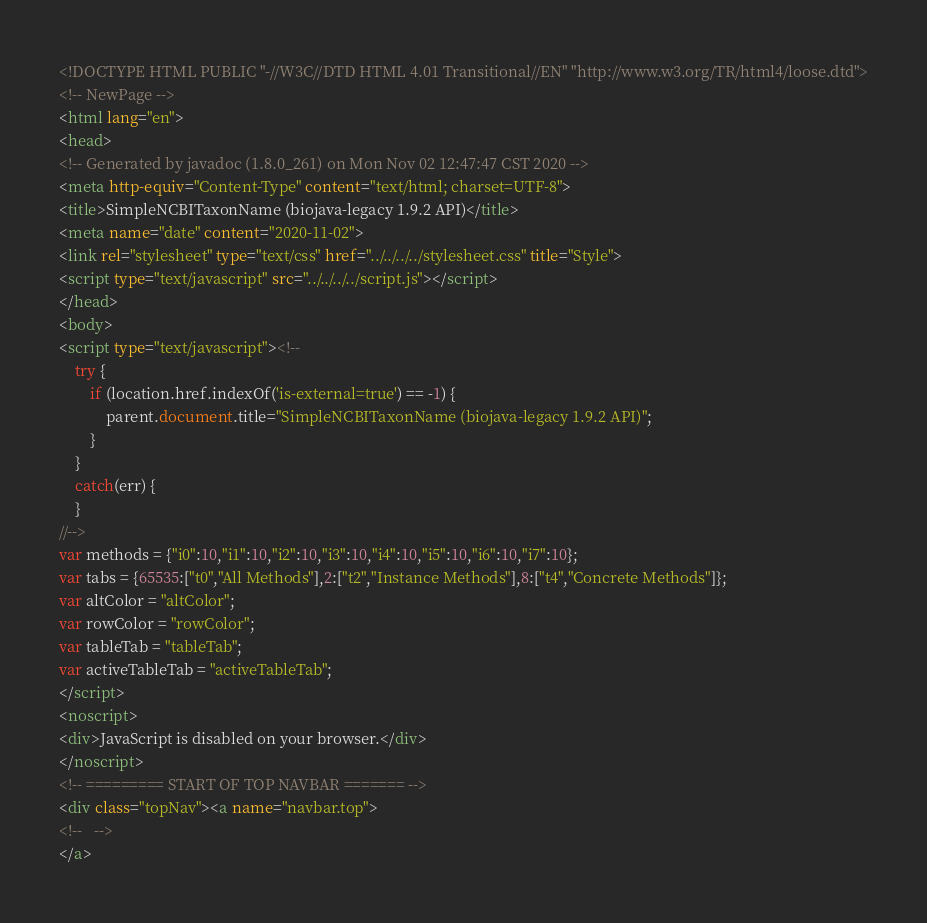<code> <loc_0><loc_0><loc_500><loc_500><_HTML_><!DOCTYPE HTML PUBLIC "-//W3C//DTD HTML 4.01 Transitional//EN" "http://www.w3.org/TR/html4/loose.dtd">
<!-- NewPage -->
<html lang="en">
<head>
<!-- Generated by javadoc (1.8.0_261) on Mon Nov 02 12:47:47 CST 2020 -->
<meta http-equiv="Content-Type" content="text/html; charset=UTF-8">
<title>SimpleNCBITaxonName (biojava-legacy 1.9.2 API)</title>
<meta name="date" content="2020-11-02">
<link rel="stylesheet" type="text/css" href="../../../../stylesheet.css" title="Style">
<script type="text/javascript" src="../../../../script.js"></script>
</head>
<body>
<script type="text/javascript"><!--
    try {
        if (location.href.indexOf('is-external=true') == -1) {
            parent.document.title="SimpleNCBITaxonName (biojava-legacy 1.9.2 API)";
        }
    }
    catch(err) {
    }
//-->
var methods = {"i0":10,"i1":10,"i2":10,"i3":10,"i4":10,"i5":10,"i6":10,"i7":10};
var tabs = {65535:["t0","All Methods"],2:["t2","Instance Methods"],8:["t4","Concrete Methods"]};
var altColor = "altColor";
var rowColor = "rowColor";
var tableTab = "tableTab";
var activeTableTab = "activeTableTab";
</script>
<noscript>
<div>JavaScript is disabled on your browser.</div>
</noscript>
<!-- ========= START OF TOP NAVBAR ======= -->
<div class="topNav"><a name="navbar.top">
<!--   -->
</a></code> 